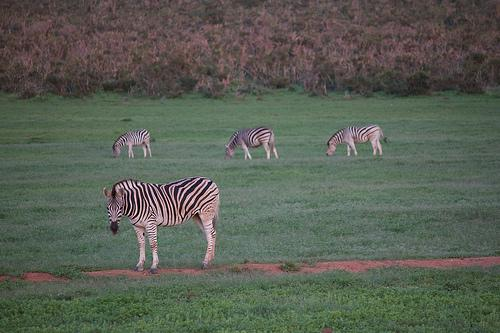Question: what animal is pictured?
Choices:
A. Monkeys.
B. Zebras.
C. Giraffes.
D. Elephants.
Answer with the letter. Answer: B Question: what color are the zebras?
Choices:
A. Brown and white.
B. Black and white.
C. White striped with black.
D. Black striped and white.
Answer with the letter. Answer: B Question: what are the zebra doing?
Choices:
A. Drinking.
B. Grazing.
C. Walking.
D. Running.
Answer with the letter. Answer: B Question: where is the brush?
Choices:
A. Near the water.
B. Behind the fence.
C. Behind the zebra.
D. On the left of the giraffes.
Answer with the letter. Answer: C Question: how many zebra are looking up?
Choices:
A. 1.
B. 2.
C. 3.
D. 4.
Answer with the letter. Answer: A 